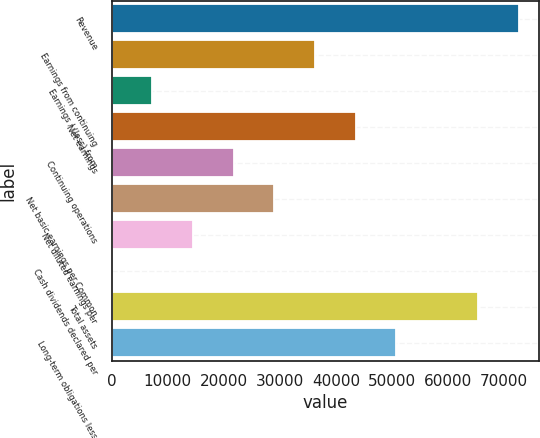Convert chart to OTSL. <chart><loc_0><loc_0><loc_500><loc_500><bar_chart><fcel>Revenue<fcel>Earnings from continuing<fcel>Earnings / (loss) from<fcel>Net earnings<fcel>Continuing operations<fcel>Net basic earnings per Common<fcel>Net diluted earnings per<fcel>Cash dividends declared per<fcel>Total assets<fcel>Long-term obligations less<nl><fcel>72579.1<fcel>36289.6<fcel>7258.05<fcel>43547.5<fcel>21773.8<fcel>29031.7<fcel>14516<fcel>0.15<fcel>65321.2<fcel>50805.4<nl></chart> 